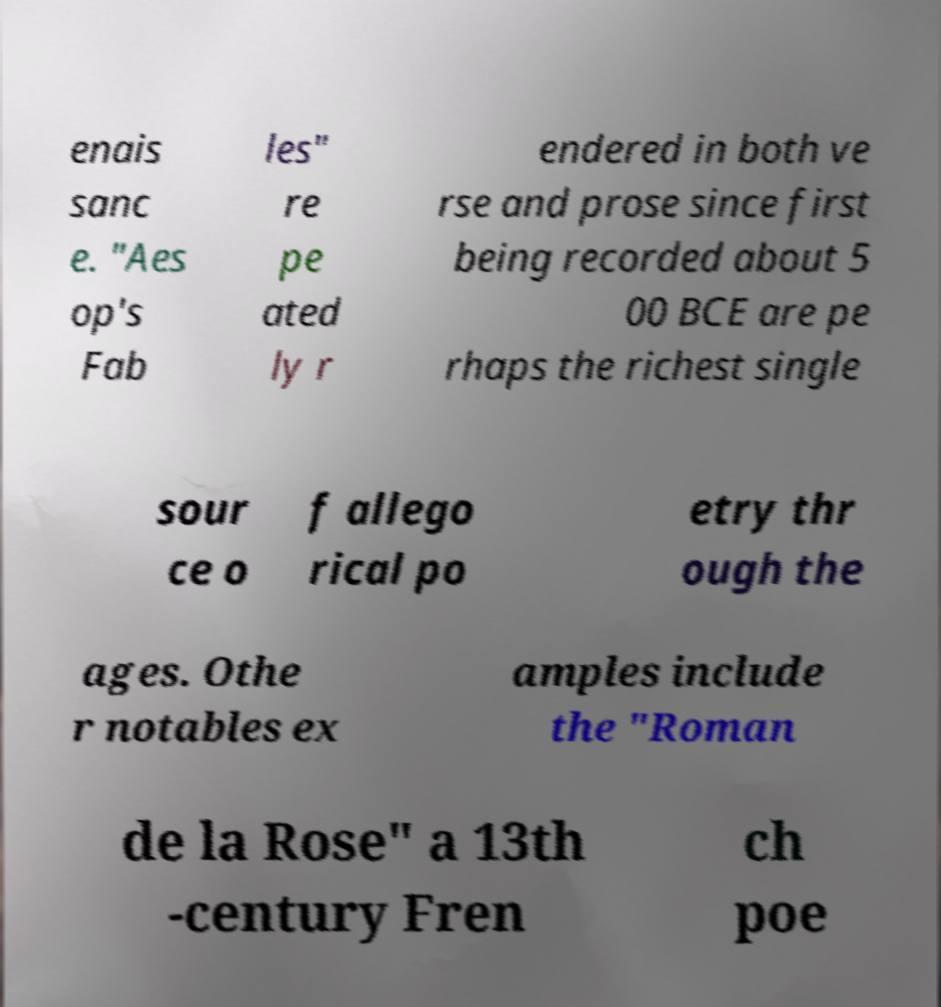Can you accurately transcribe the text from the provided image for me? enais sanc e. "Aes op's Fab les" re pe ated ly r endered in both ve rse and prose since first being recorded about 5 00 BCE are pe rhaps the richest single sour ce o f allego rical po etry thr ough the ages. Othe r notables ex amples include the "Roman de la Rose" a 13th -century Fren ch poe 